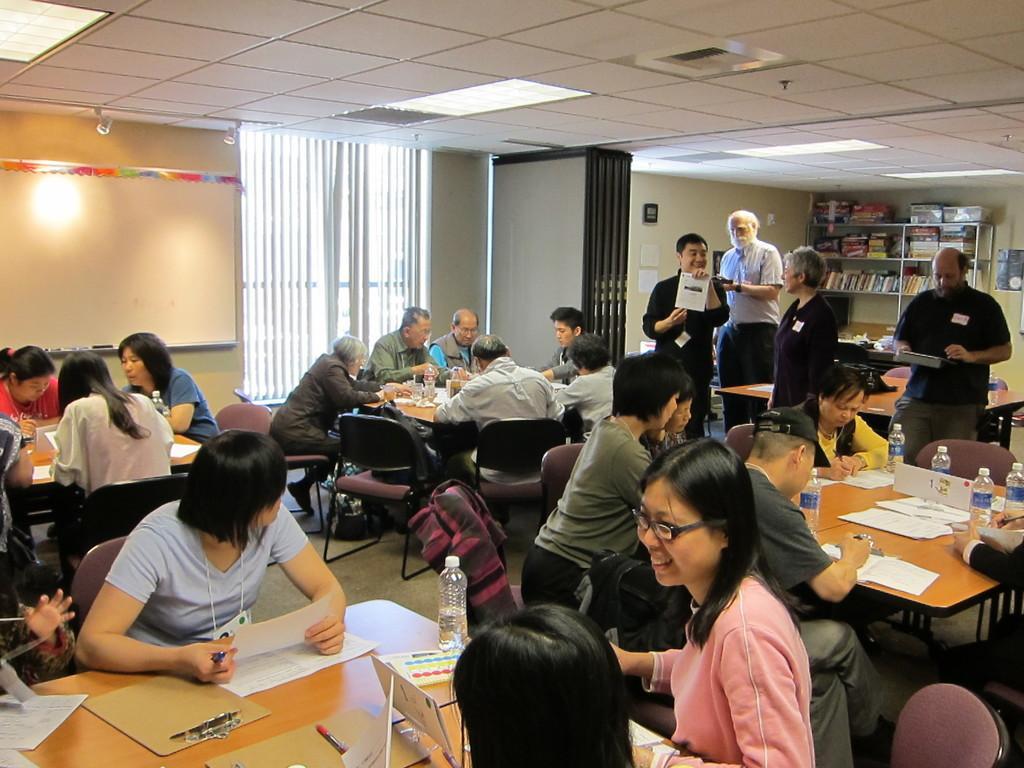In one or two sentences, can you explain what this image depicts? In the image in the center, we can see a few people are sitting around the table. On the table, we can see the papers, pens, water bottles and a few other objects. In the background there is a wall, curtain, roof, lights, racks, books and few people are standing. 